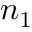Convert formula to latex. <formula><loc_0><loc_0><loc_500><loc_500>n _ { 1 }</formula> 